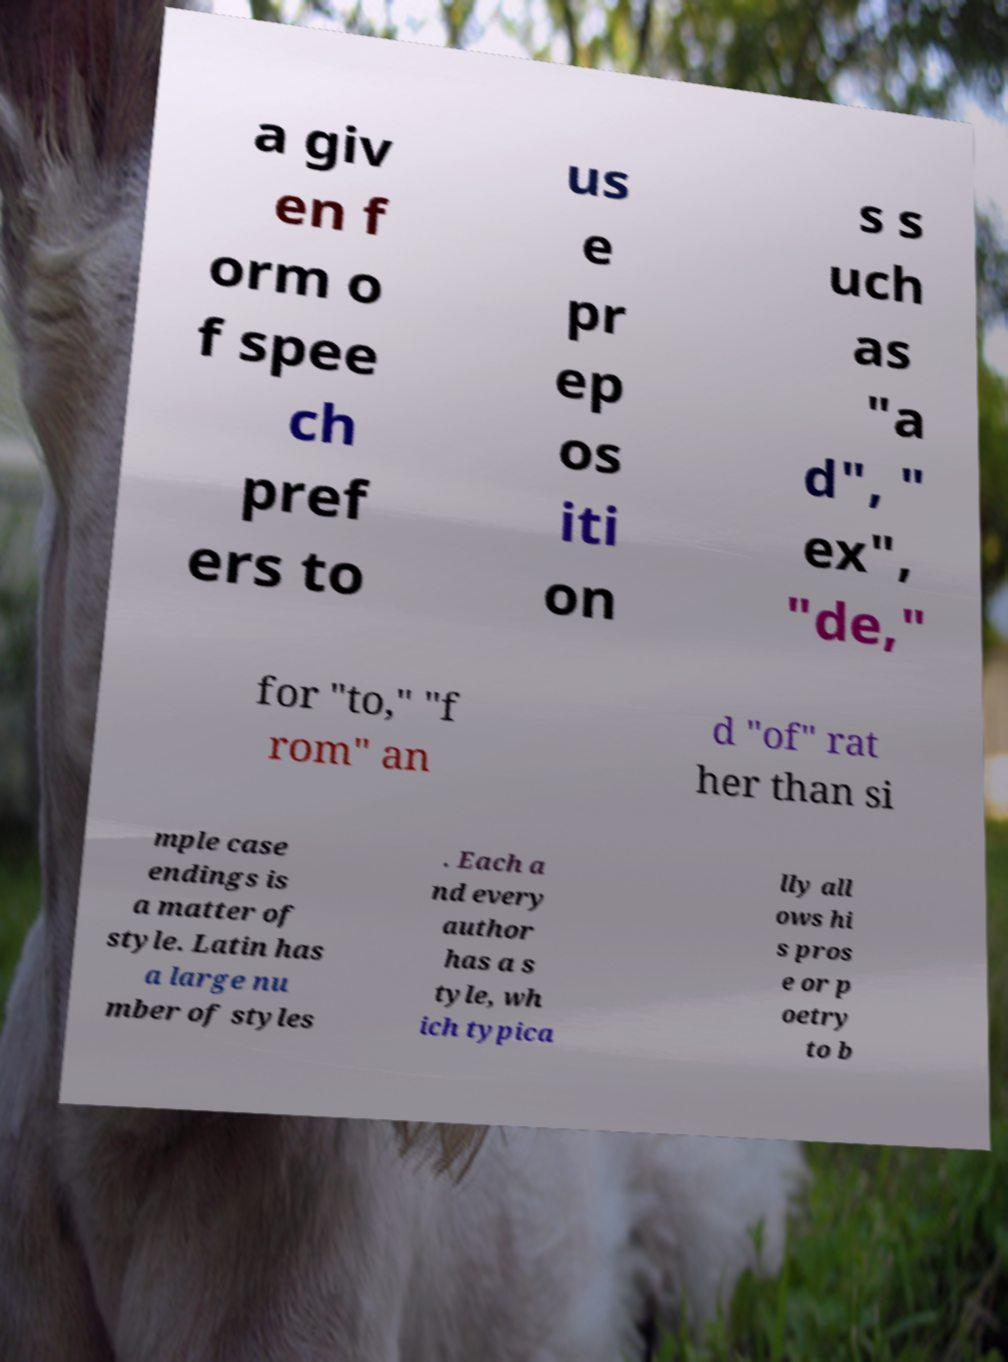Can you read and provide the text displayed in the image?This photo seems to have some interesting text. Can you extract and type it out for me? a giv en f orm o f spee ch pref ers to us e pr ep os iti on s s uch as "a d", " ex", "de," for "to," "f rom" an d "of" rat her than si mple case endings is a matter of style. Latin has a large nu mber of styles . Each a nd every author has a s tyle, wh ich typica lly all ows hi s pros e or p oetry to b 